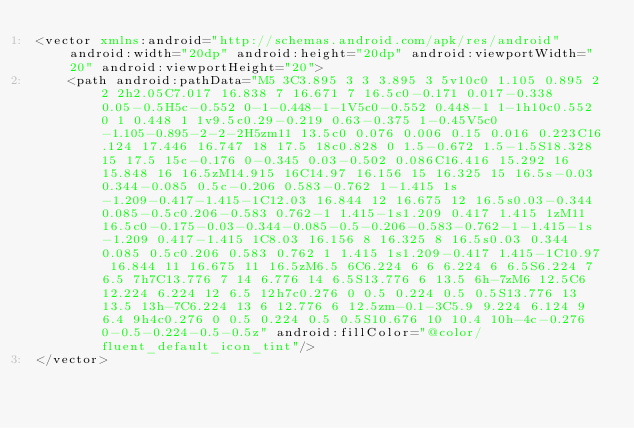Convert code to text. <code><loc_0><loc_0><loc_500><loc_500><_XML_><vector xmlns:android="http://schemas.android.com/apk/res/android" android:width="20dp" android:height="20dp" android:viewportWidth="20" android:viewportHeight="20">
    <path android:pathData="M5 3C3.895 3 3 3.895 3 5v10c0 1.105 0.895 2 2 2h2.05C7.017 16.838 7 16.671 7 16.5c0-0.171 0.017-0.338 0.05-0.5H5c-0.552 0-1-0.448-1-1V5c0-0.552 0.448-1 1-1h10c0.552 0 1 0.448 1 1v9.5c0.29-0.219 0.63-0.375 1-0.45V5c0-1.105-0.895-2-2-2H5zm11 13.5c0 0.076 0.006 0.15 0.016 0.223C16.124 17.446 16.747 18 17.5 18c0.828 0 1.5-0.672 1.5-1.5S18.328 15 17.5 15c-0.176 0-0.345 0.03-0.502 0.086C16.416 15.292 16 15.848 16 16.5zM14.915 16C14.97 16.156 15 16.325 15 16.5s-0.03 0.344-0.085 0.5c-0.206 0.583-0.762 1-1.415 1s-1.209-0.417-1.415-1C12.03 16.844 12 16.675 12 16.5s0.03-0.344 0.085-0.5c0.206-0.583 0.762-1 1.415-1s1.209 0.417 1.415 1zM11 16.5c0-0.175-0.03-0.344-0.085-0.5-0.206-0.583-0.762-1-1.415-1s-1.209 0.417-1.415 1C8.03 16.156 8 16.325 8 16.5s0.03 0.344 0.085 0.5c0.206 0.583 0.762 1 1.415 1s1.209-0.417 1.415-1C10.97 16.844 11 16.675 11 16.5zM6.5 6C6.224 6 6 6.224 6 6.5S6.224 7 6.5 7h7C13.776 7 14 6.776 14 6.5S13.776 6 13.5 6h-7zM6 12.5C6 12.224 6.224 12 6.5 12h7c0.276 0 0.5 0.224 0.5 0.5S13.776 13 13.5 13h-7C6.224 13 6 12.776 6 12.5zm-0.1-3C5.9 9.224 6.124 9 6.4 9h4c0.276 0 0.5 0.224 0.5 0.5S10.676 10 10.4 10h-4c-0.276 0-0.5-0.224-0.5-0.5z" android:fillColor="@color/fluent_default_icon_tint"/>
</vector>
</code> 